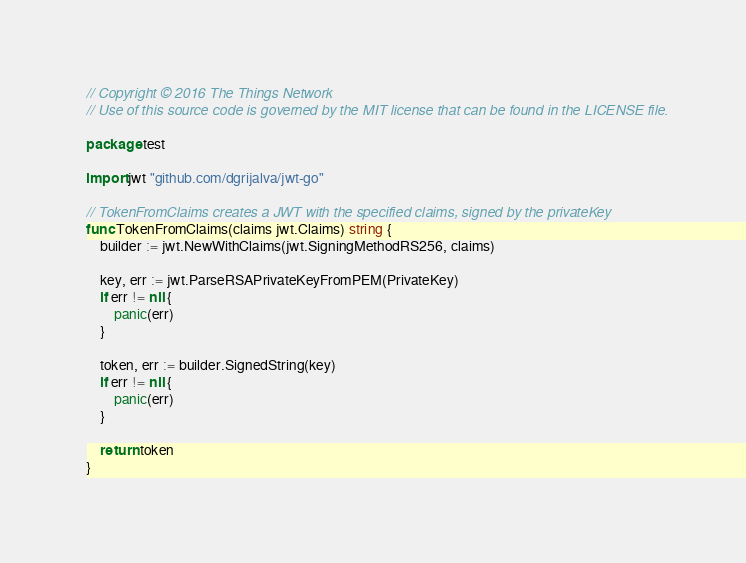Convert code to text. <code><loc_0><loc_0><loc_500><loc_500><_Go_>// Copyright © 2016 The Things Network
// Use of this source code is governed by the MIT license that can be found in the LICENSE file.

package test

import jwt "github.com/dgrijalva/jwt-go"

// TokenFromClaims creates a JWT with the specified claims, signed by the privateKey
func TokenFromClaims(claims jwt.Claims) string {
	builder := jwt.NewWithClaims(jwt.SigningMethodRS256, claims)

	key, err := jwt.ParseRSAPrivateKeyFromPEM(PrivateKey)
	if err != nil {
		panic(err)
	}

	token, err := builder.SignedString(key)
	if err != nil {
		panic(err)
	}

	return token
}
</code> 